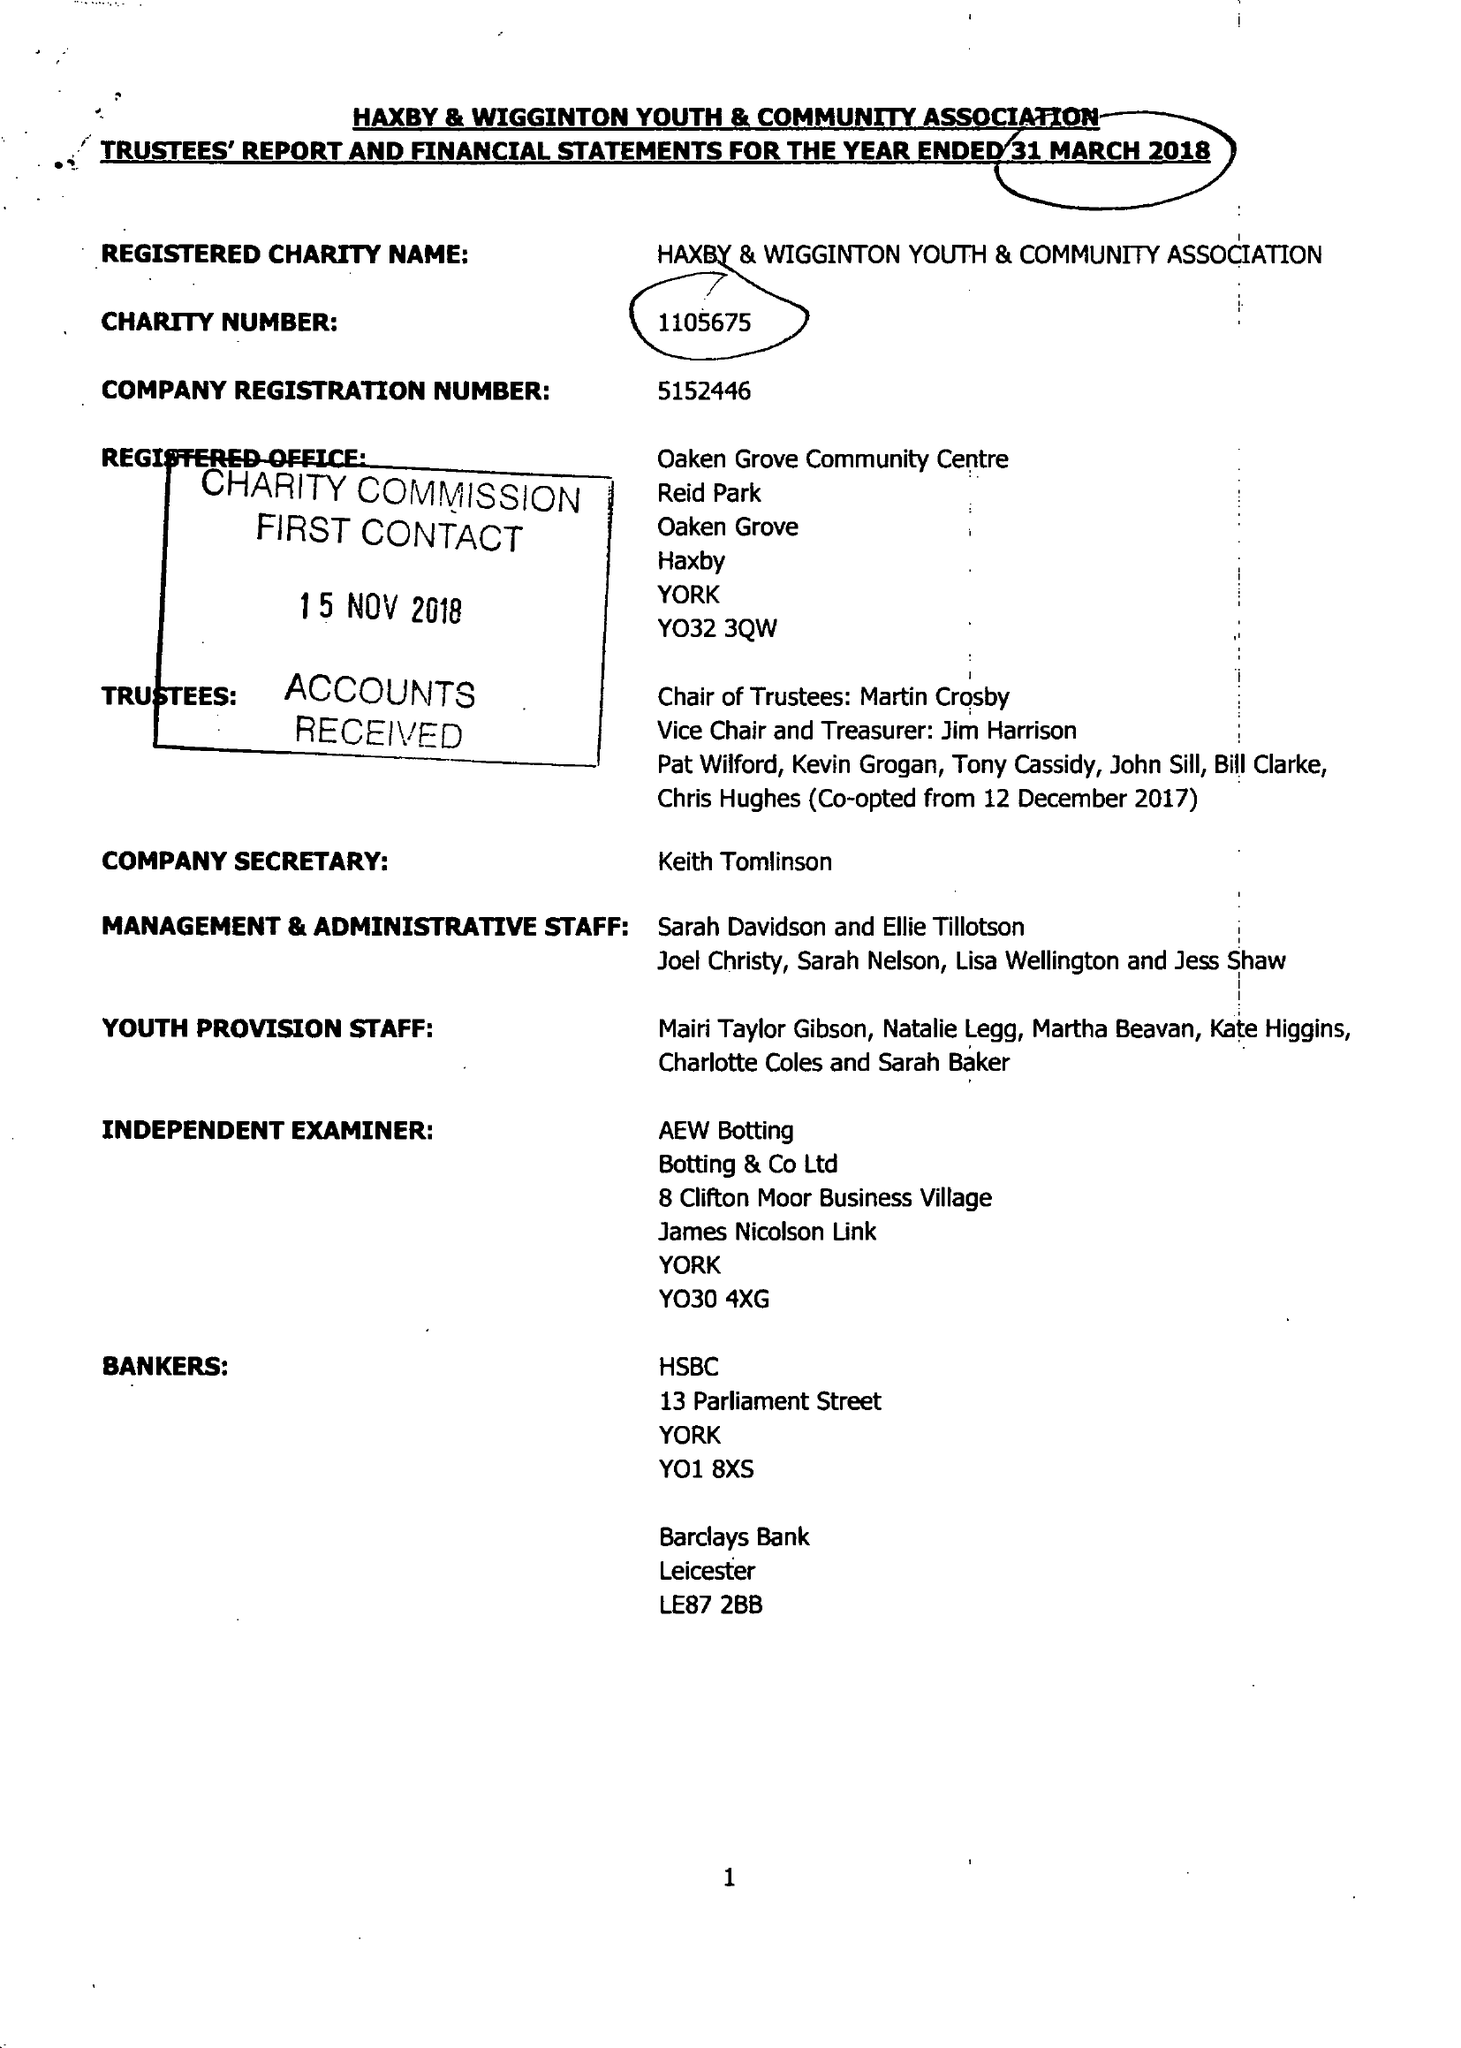What is the value for the report_date?
Answer the question using a single word or phrase. 2018-03-31 